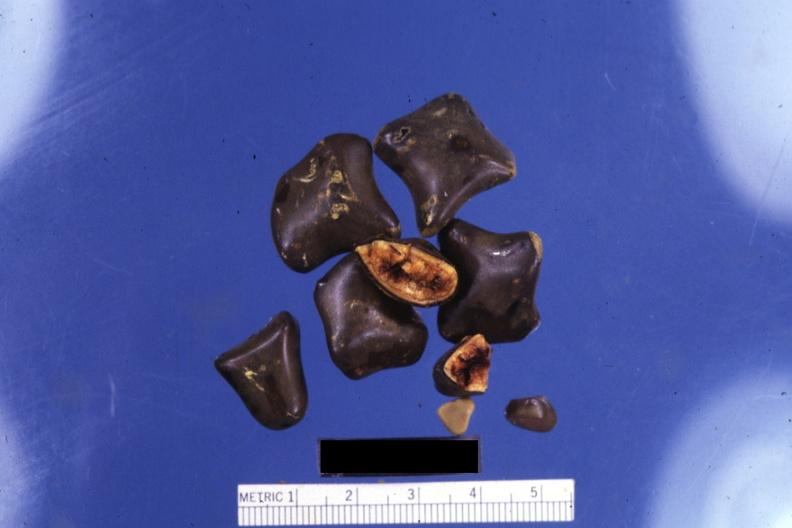what is present?
Answer the question using a single word or phrase. Liver 